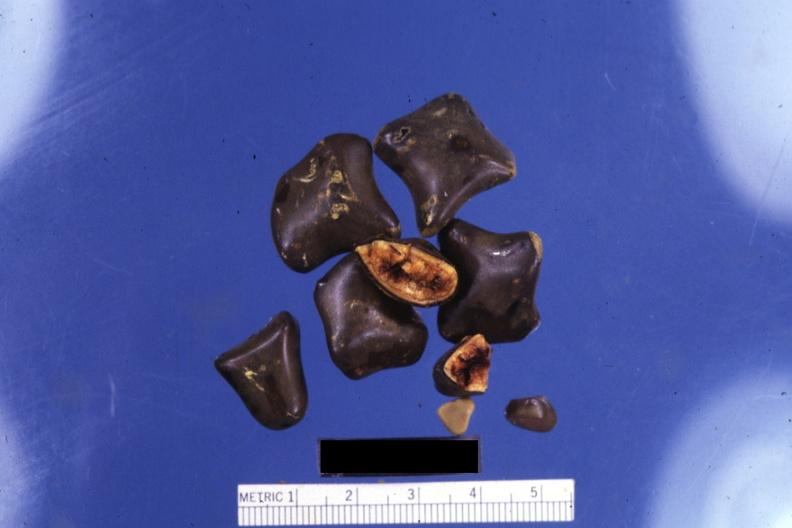what is present?
Answer the question using a single word or phrase. Liver 